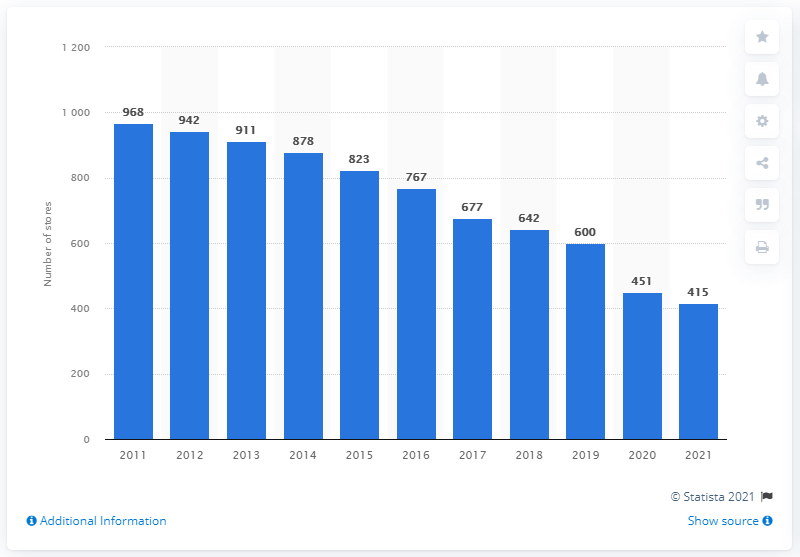Give some essential details in this illustration. Reitmans operated 415 stores in Canada in 2021. 